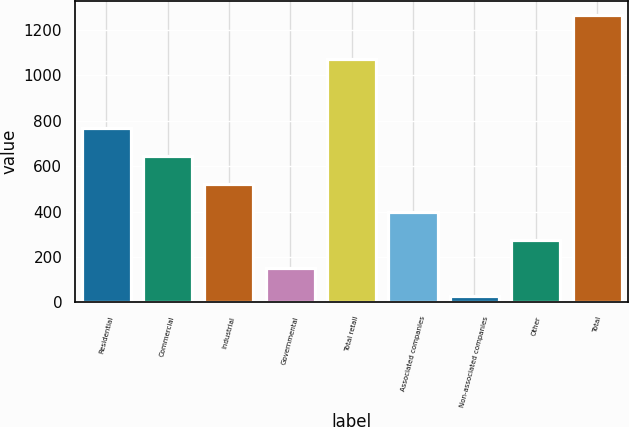Convert chart to OTSL. <chart><loc_0><loc_0><loc_500><loc_500><bar_chart><fcel>Residential<fcel>Commercial<fcel>Industrial<fcel>Governmental<fcel>Total retail<fcel>Associated companies<fcel>Non-associated companies<fcel>Other<fcel>Total<nl><fcel>770.4<fcel>646.5<fcel>522.6<fcel>150.9<fcel>1074<fcel>398.7<fcel>27<fcel>274.8<fcel>1266<nl></chart> 